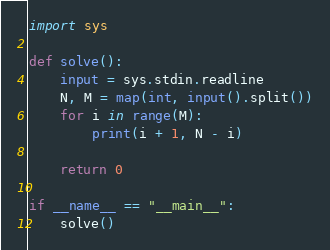Convert code to text. <code><loc_0><loc_0><loc_500><loc_500><_Python_>import sys

def solve():
    input = sys.stdin.readline
    N, M = map(int, input().split())
    for i in range(M):
        print(i + 1, N - i)

    return 0

if __name__ == "__main__":
    solve()</code> 